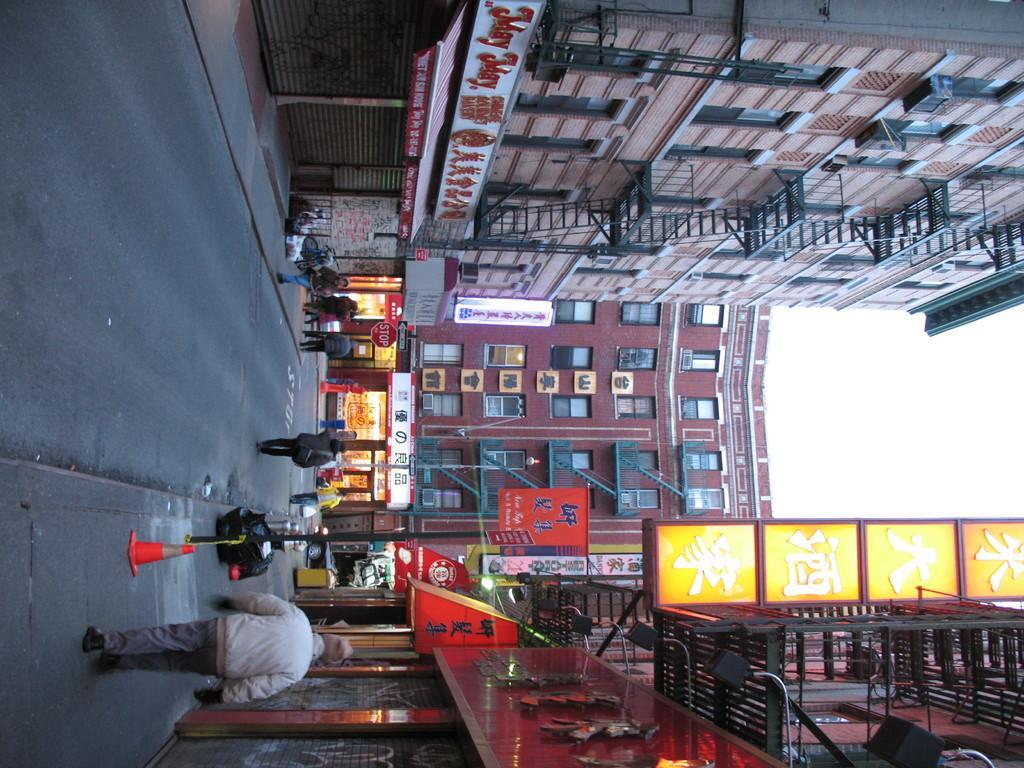Please provide a concise description of this image. In this image there are a few people walking on the streets, in front of the street there is a building with shops, on the either side of the shops there are buildings. 